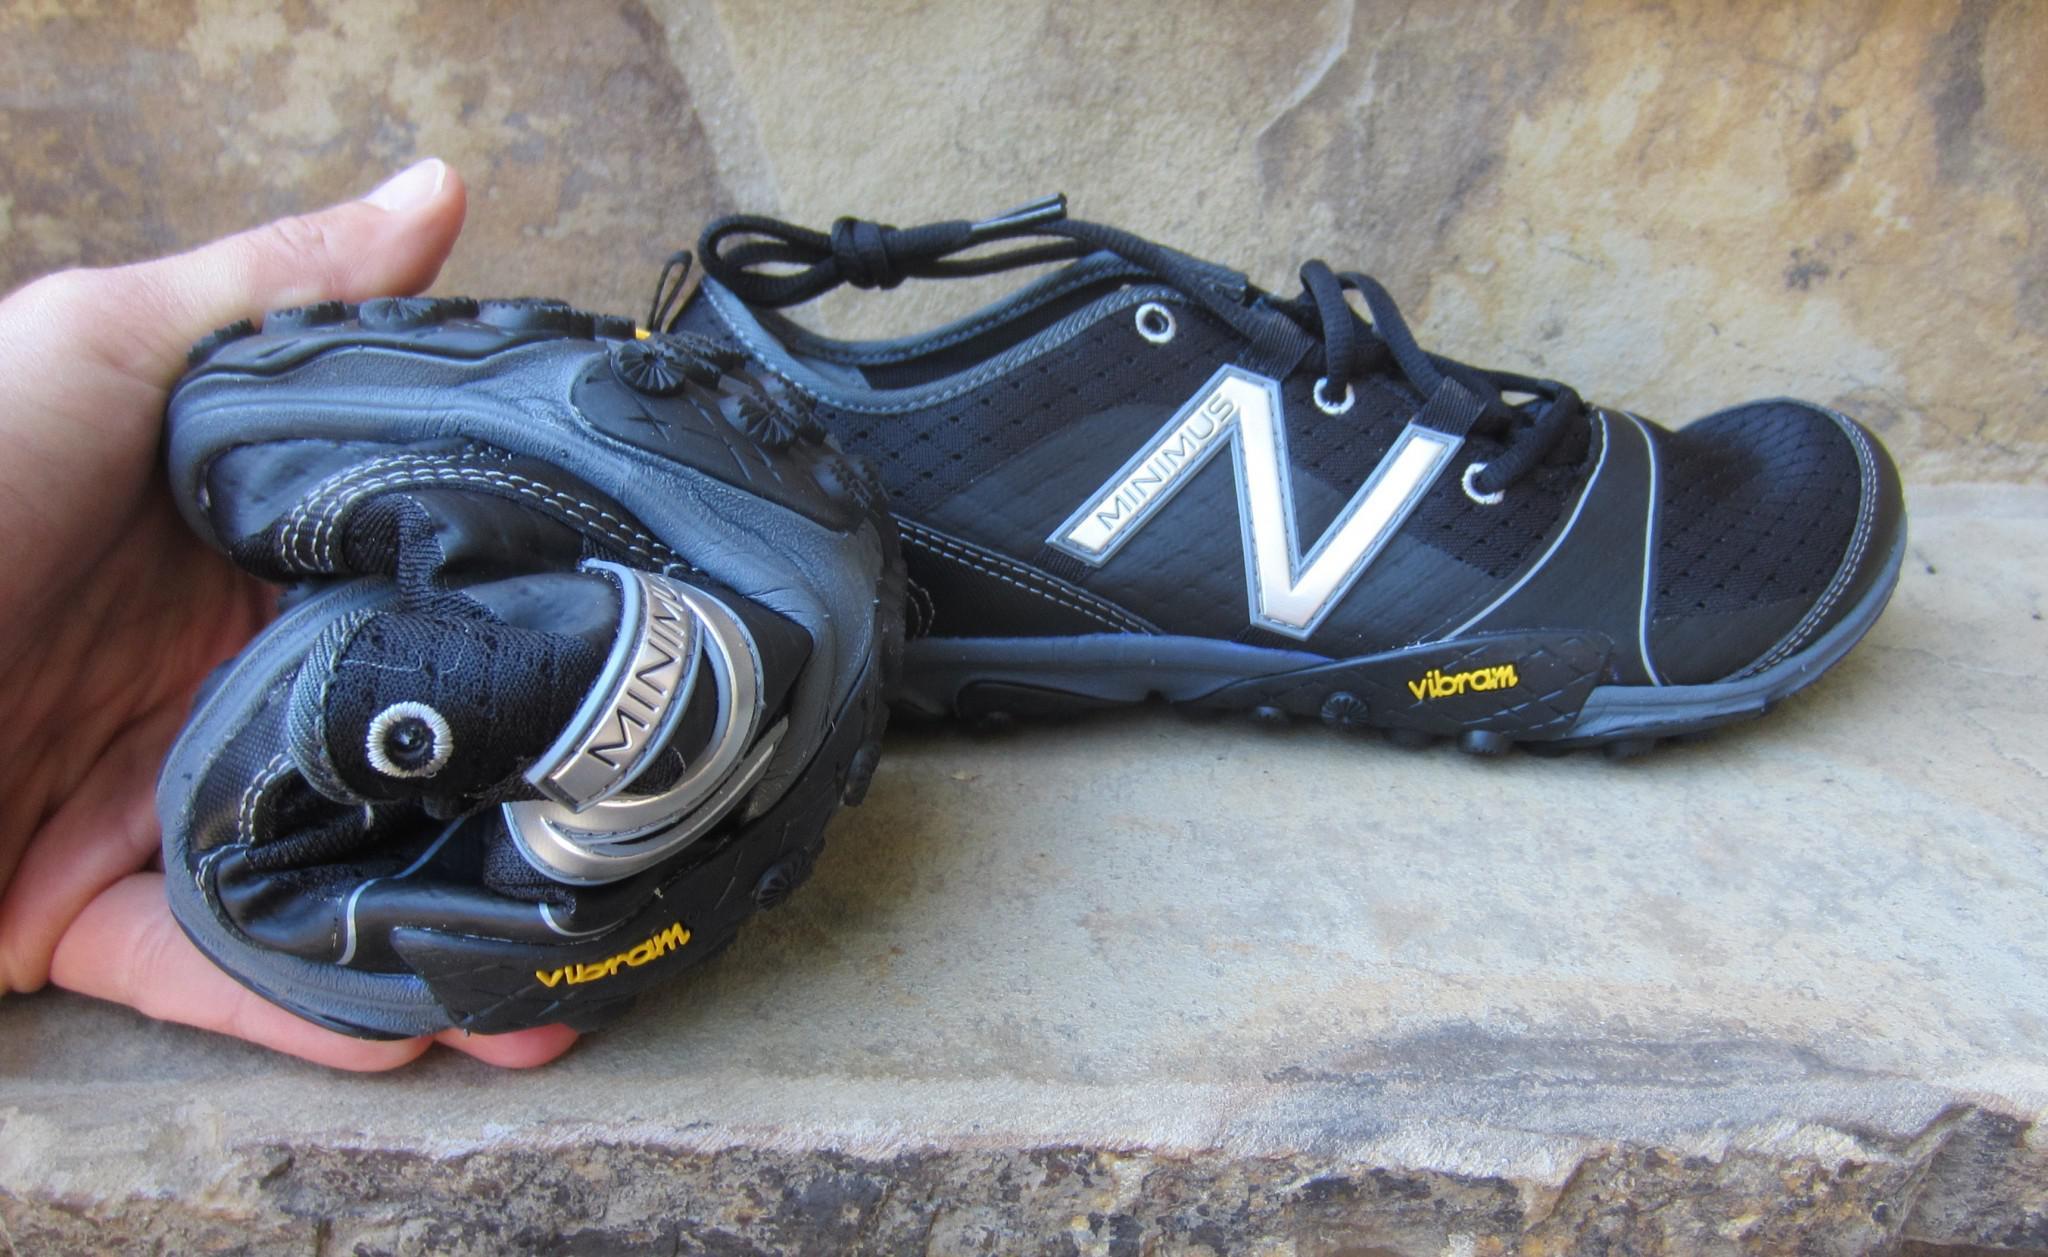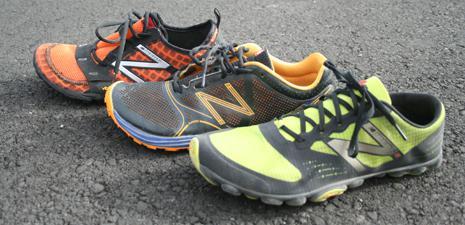The first image is the image on the left, the second image is the image on the right. For the images shown, is this caption "In total, two pairs of sneakers are shown." true? Answer yes or no. No. 